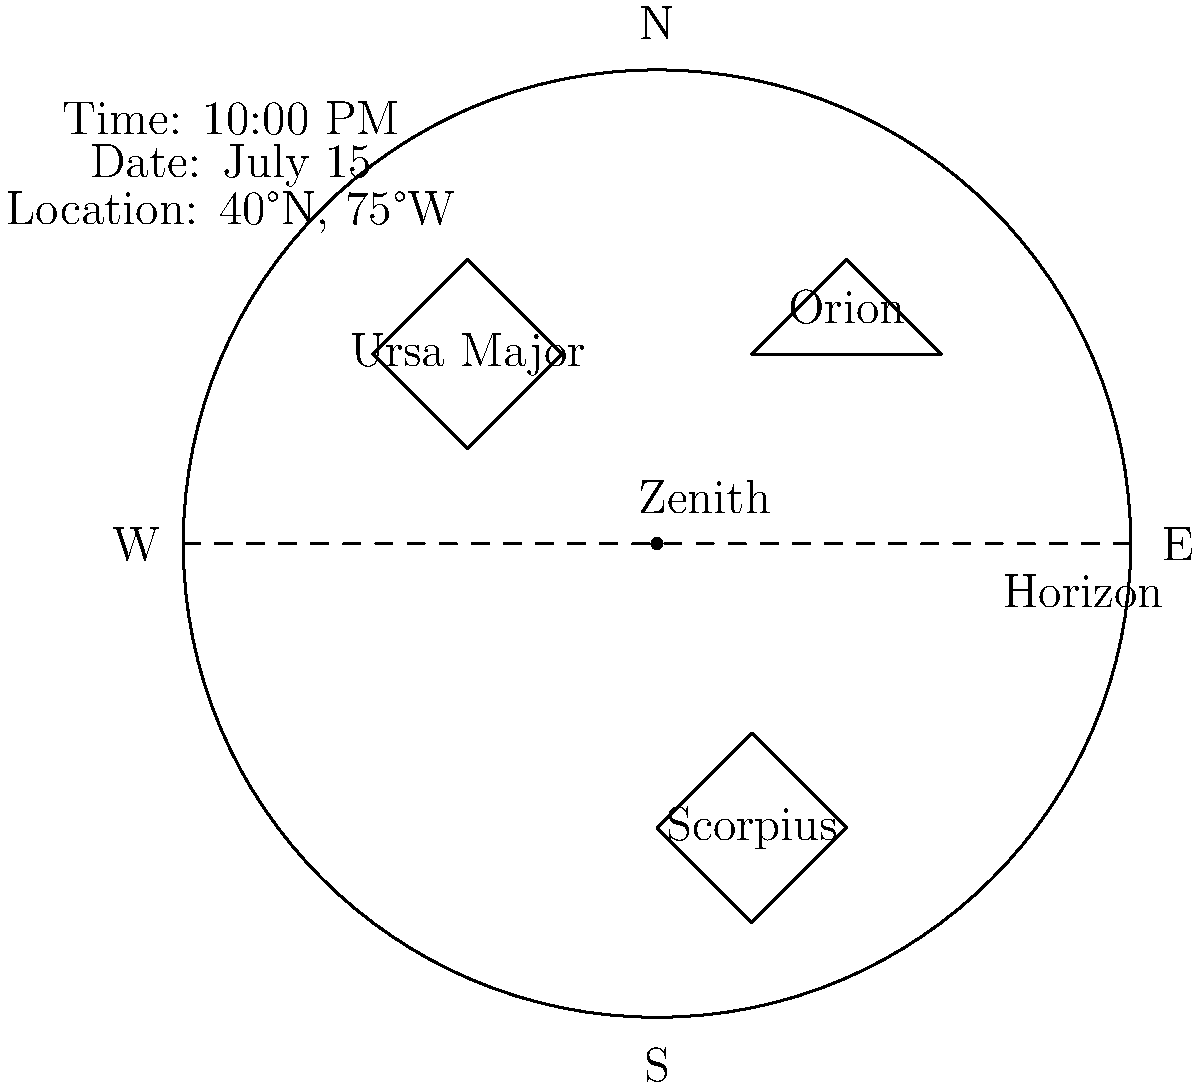Using the star chart provided, which constellation is currently highest in the sky and most visible to customers viewing from this location? To determine which constellation is highest in the sky and most visible, we need to follow these steps:

1. Understand the star chart:
   - The circle represents the entire visible sky.
   - The center of the circle represents the zenith (the point directly overhead).
   - The edge of the circle represents the horizon.
   - North is at the top, South at the bottom, East to the right, and West to the left.

2. Identify the constellations on the chart:
   - Orion is visible in the lower right quadrant.
   - Ursa Major is visible in the upper left quadrant.
   - Scorpius is visible near the bottom of the chart.

3. Assess the position of each constellation:
   - Orion is above the horizon but not very high in the sky.
   - Ursa Major is well above the horizon and closer to the zenith.
   - Scorpius is just above the horizon in the south.

4. Consider the time and date:
   - The chart shows 10:00 PM on July 15.
   - This summer date affects the visibility of constellations.

5. Take into account the location:
   - The location is 40°N, 75°W, which is in the mid-northern latitudes.

6. Determine the highest constellation:
   - Of the three constellations shown, Ursa Major is closest to the zenith.
   - It is well above the horizon and higher than both Orion and Scorpius.

Therefore, based on this star chart, Ursa Major is currently the highest in the sky and most visible to customers viewing from this location.
Answer: Ursa Major 